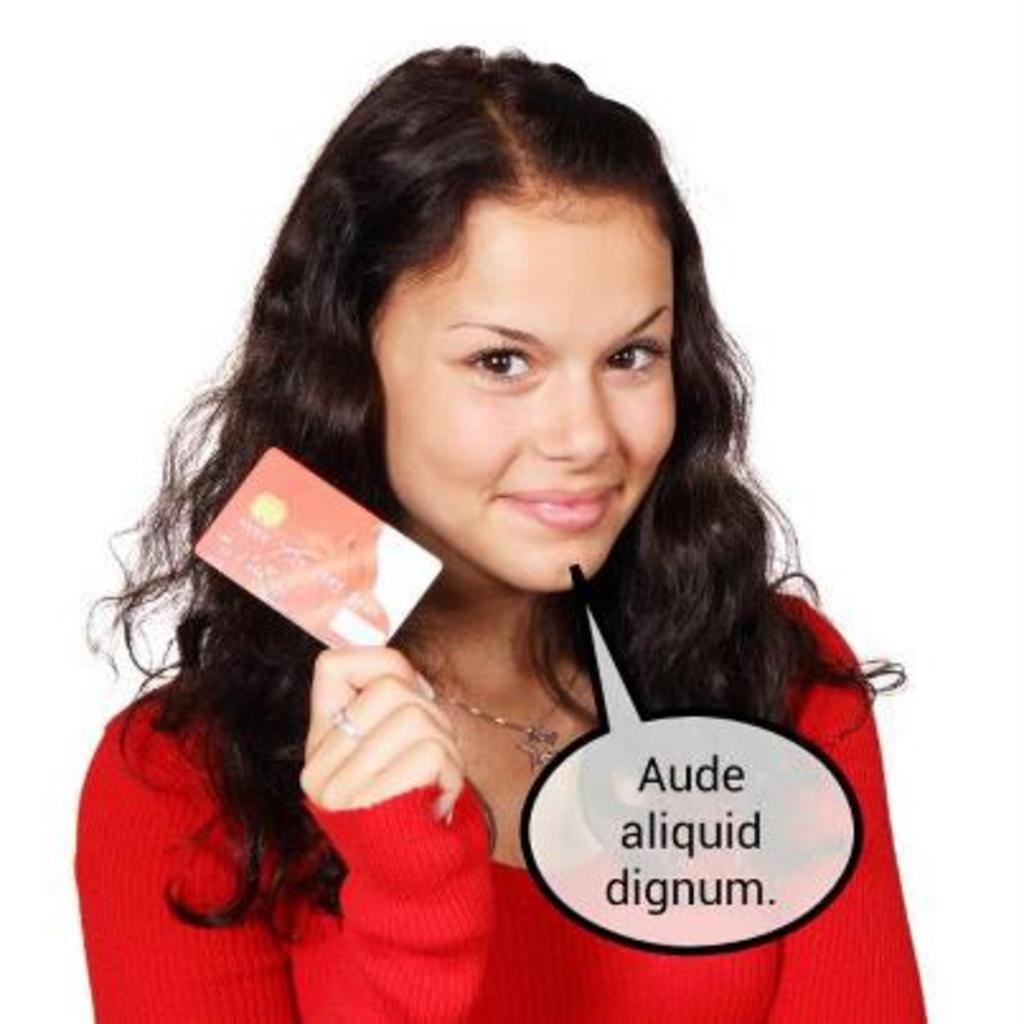Please provide a concise description of this image. This looks like an edited image. I can see the woman standing and smiling. She is holding a card in her hand. She wore a red color dress. I think this is the watermark on the image. The background looks white in color. 